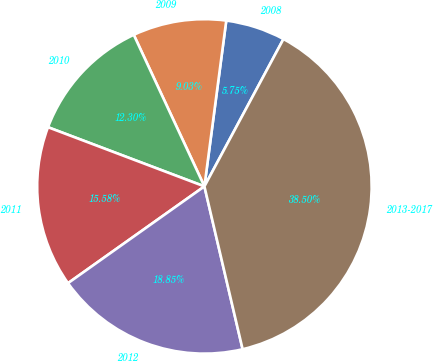Convert chart. <chart><loc_0><loc_0><loc_500><loc_500><pie_chart><fcel>2008<fcel>2009<fcel>2010<fcel>2011<fcel>2012<fcel>2013-2017<nl><fcel>5.75%<fcel>9.03%<fcel>12.3%<fcel>15.58%<fcel>18.85%<fcel>38.5%<nl></chart> 